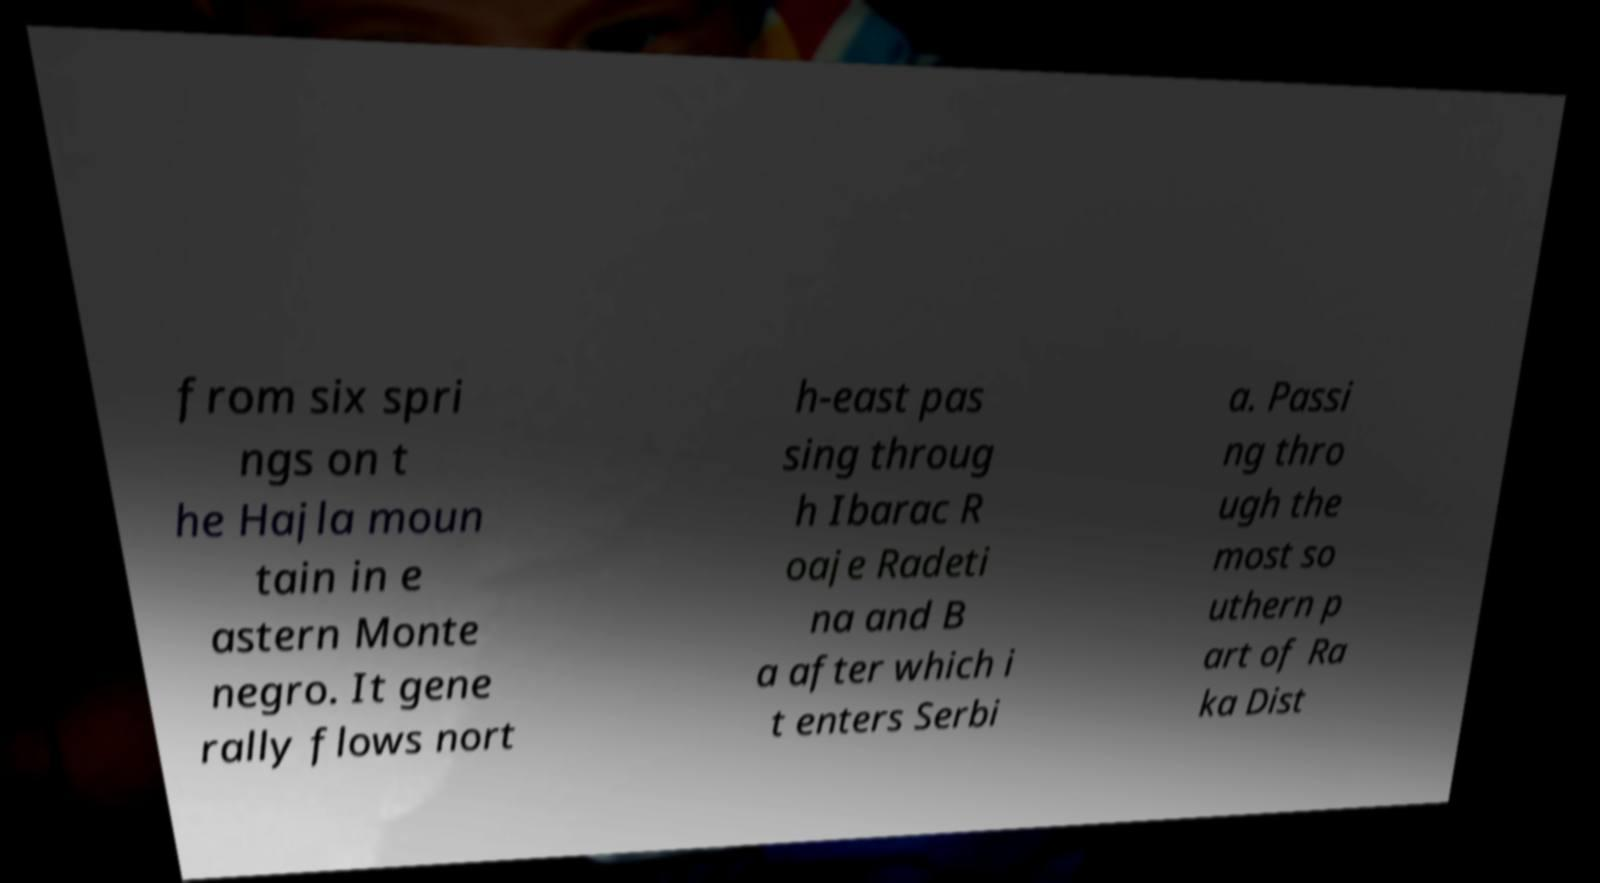What messages or text are displayed in this image? I need them in a readable, typed format. from six spri ngs on t he Hajla moun tain in e astern Monte negro. It gene rally flows nort h-east pas sing throug h Ibarac R oaje Radeti na and B a after which i t enters Serbi a. Passi ng thro ugh the most so uthern p art of Ra ka Dist 